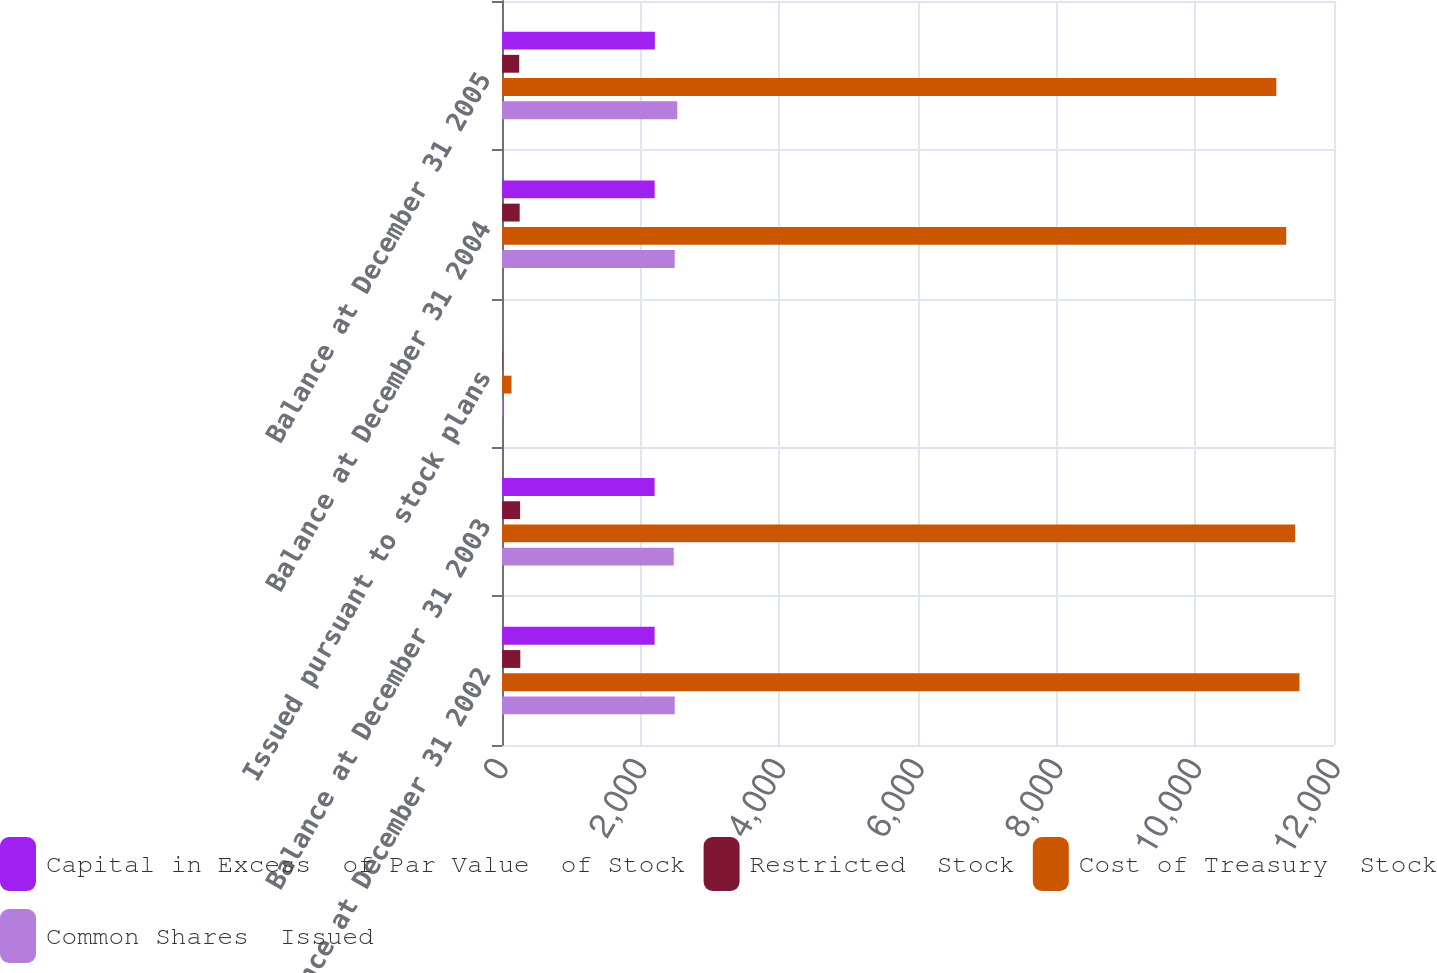Convert chart to OTSL. <chart><loc_0><loc_0><loc_500><loc_500><stacked_bar_chart><ecel><fcel>Balance at December 31 2002<fcel>Balance at December 31 2003<fcel>Issued pursuant to stock plans<fcel>Balance at December 31 2004<fcel>Balance at December 31 2005<nl><fcel>Capital in Excess  of Par Value  of Stock<fcel>2201<fcel>2201<fcel>1<fcel>2202<fcel>2205<nl><fcel>Restricted  Stock<fcel>264<fcel>261<fcel>6<fcel>255<fcel>248<nl><fcel>Cost of Treasury  Stock<fcel>11502<fcel>11440<fcel>137<fcel>11311<fcel>11168<nl><fcel>Common Shares  Issued<fcel>2491<fcel>2477<fcel>12<fcel>2491<fcel>2528<nl></chart> 